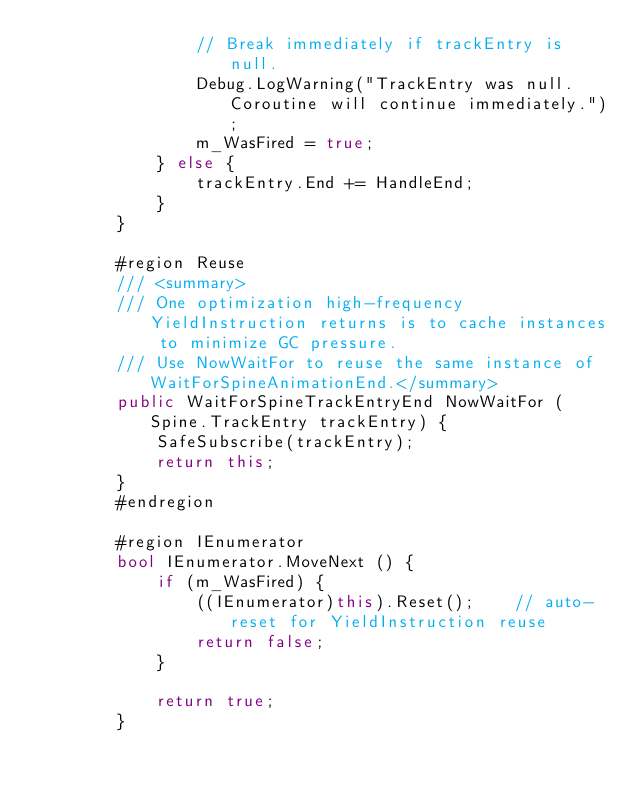<code> <loc_0><loc_0><loc_500><loc_500><_C#_>				// Break immediately if trackEntry is null.
				Debug.LogWarning("TrackEntry was null. Coroutine will continue immediately.");
				m_WasFired = true;
			} else {
				trackEntry.End += HandleEnd;
			}
		}

		#region Reuse
		/// <summary>
		/// One optimization high-frequency YieldInstruction returns is to cache instances to minimize GC pressure.
		/// Use NowWaitFor to reuse the same instance of WaitForSpineAnimationEnd.</summary>
		public WaitForSpineTrackEntryEnd NowWaitFor (Spine.TrackEntry trackEntry) {
			SafeSubscribe(trackEntry);
			return this;
		}
		#endregion

		#region IEnumerator
		bool IEnumerator.MoveNext () {
			if (m_WasFired) {
				((IEnumerator)this).Reset();	// auto-reset for YieldInstruction reuse
				return false;
			}

			return true;
		}</code> 